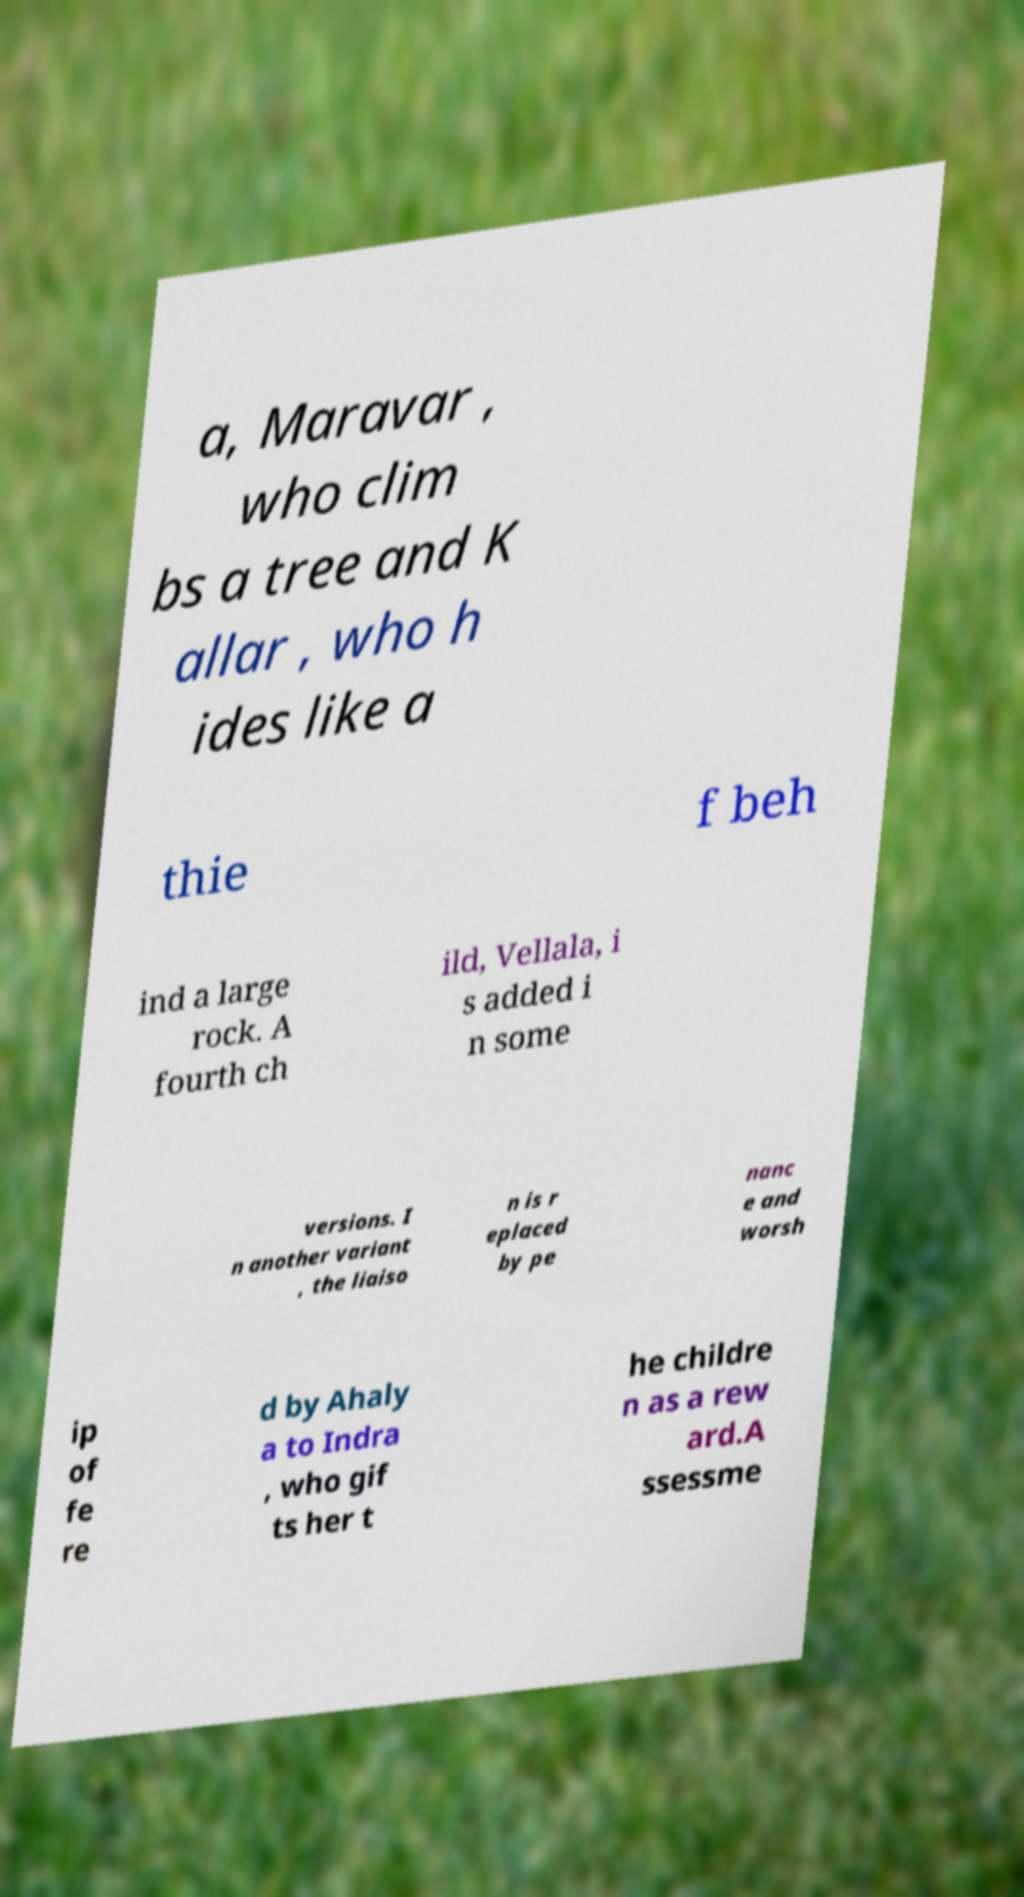For documentation purposes, I need the text within this image transcribed. Could you provide that? a, Maravar , who clim bs a tree and K allar , who h ides like a thie f beh ind a large rock. A fourth ch ild, Vellala, i s added i n some versions. I n another variant , the liaiso n is r eplaced by pe nanc e and worsh ip of fe re d by Ahaly a to Indra , who gif ts her t he childre n as a rew ard.A ssessme 